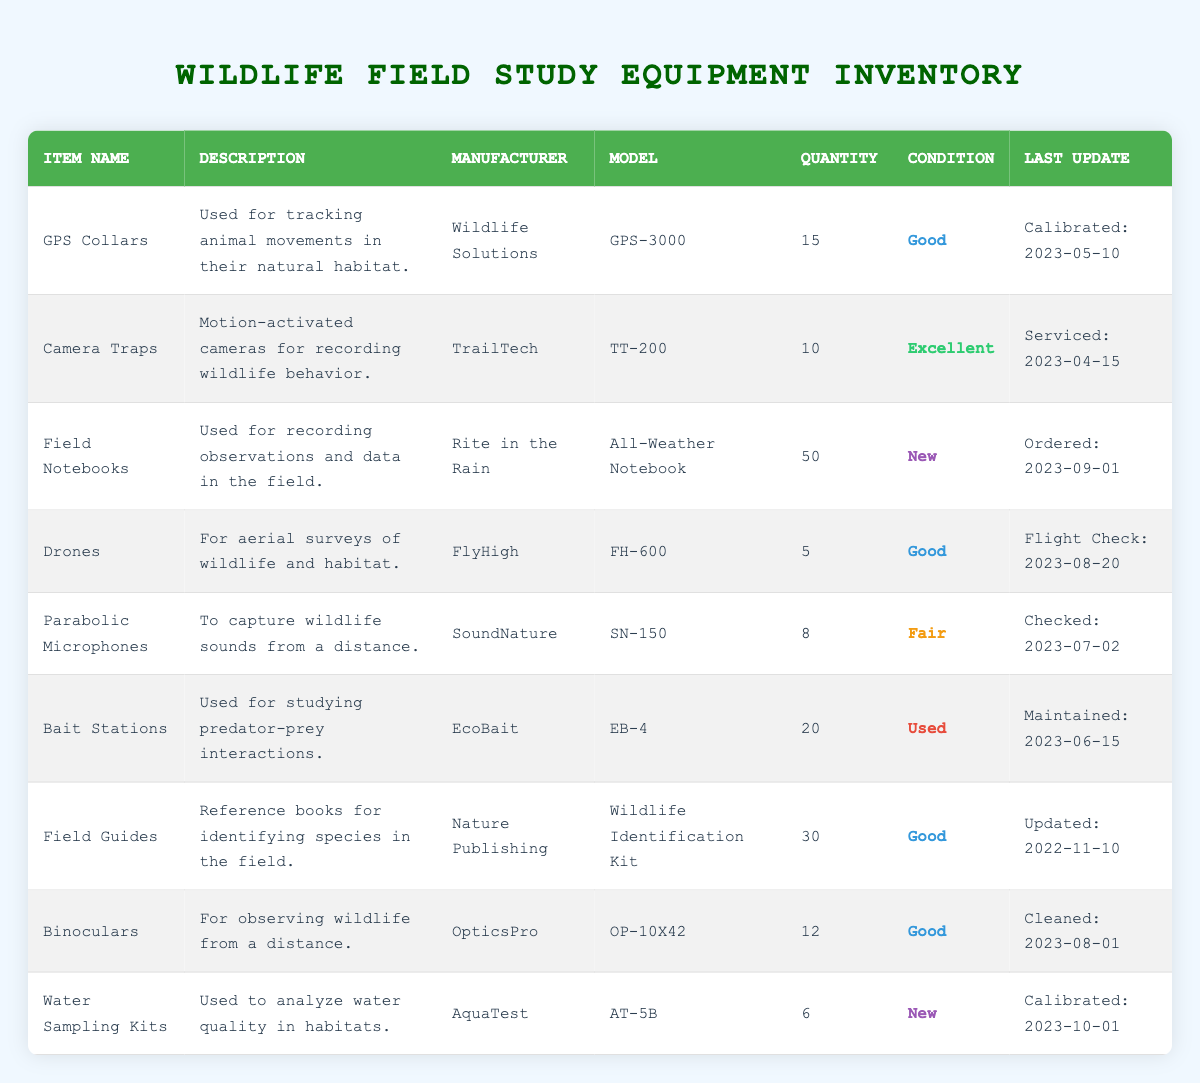What is the total quantity of items in the inventory? To find the total quantity, add up the quantity of each item: 15 (GPS Collars) + 10 (Camera Traps) + 50 (Field Notebooks) + 5 (Drones) + 8 (Parabolic Microphones) + 20 (Bait Stations) + 30 (Field Guides) + 12 (Binoculars) + 6 (Water Sampling Kits) =  15 + 10 + 50 + 5 + 8 + 20 + 30 + 12 + 6 =  156
Answer: 156 How many items are in "New" condition? Looking at the condition column, the items in "New" condition are: Field Notebooks (50) and Water Sampling Kits (6). Thus, there are a total of 2 items in "New" condition.
Answer: 2 Is there any equipment used for tracking animal movements? Yes, the GPS Collars are specifically used for tracking animal movements in their natural habitat, as stated in the description of that item.
Answer: Yes Which item has the least quantity in the inventory? The item with the least quantity is the Water Sampling Kits, with a quantity of 6. By comparing all the quantities in the inventory, it's the smallest number.
Answer: Water Sampling Kits What is the average condition of the items in the inventory? To assess the average condition, we can categorize them: Excellent (1), Good (4), Fair (1), Used (1), New (2).  Assigning numerical values helps determine the average if necessary, but in general terms, there are more "Good" and "New" items in the list. The predominant condition across most items is "Good."
Answer: Good How many items are maintained or calibrated in 2023? Among the items, the following were maintained: GPS Collars (Calibrated on 2023-05-10), Camera Traps (Serviced on 2023-04-15), Drones (Flight Check on 2023-08-20), Parabolic Microphones (Checked on 2023-07-02), Bait Stations (Maintained on 2023-06-15), and Water Sampling Kits (Calibrated on 2023-10-01). This sums up to 6 items that had maintenance or calibration in 2023.
Answer: 6 Are there more "Good" or "Used" items in the inventory? There are 4 items listed as "Good" (which are GPS Collars, Drones, Field Guides, and Binoculars) and 1 item listed as "Used" (Bait Stations). Therefore, there are more "Good" items than "Used" items.
Answer: More "Good" items What are the manufacturers of the items that capture wildlife sounds? The item that captures wildlife sounds is the Parabolic Microphones, manufactured by SoundNature. This information can be found in the description and manufacturer columns for that specific item.
Answer: SoundNature 